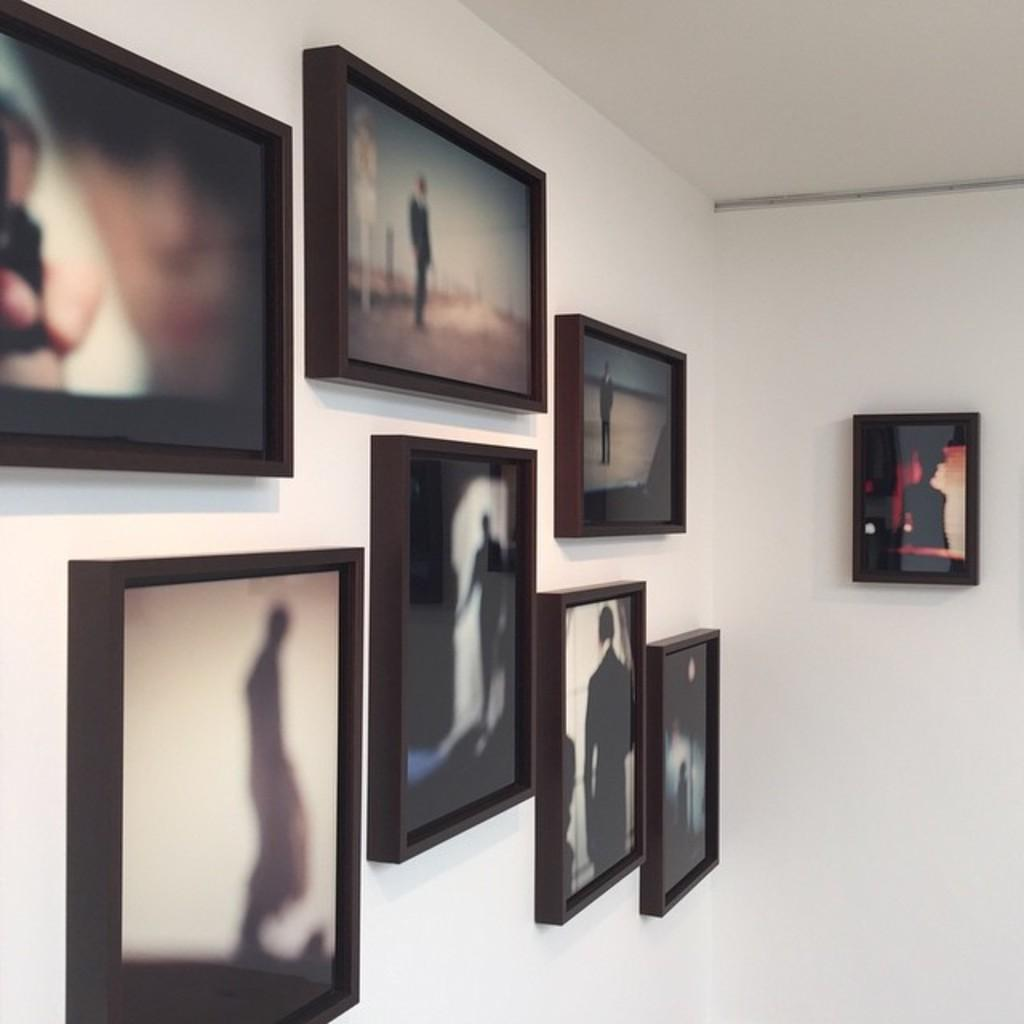What is the color of the wall in the image? The wall in the image is white. What is hung on the wall? There are photo frames on the wall. What can be seen inside the photo frames? Each photo frame contains a picture of a person. Can you tell me how many people are wishing in the garden in the image? There is no garden or people wishing in the image; it only features a white wall with photo frames containing pictures of people. 